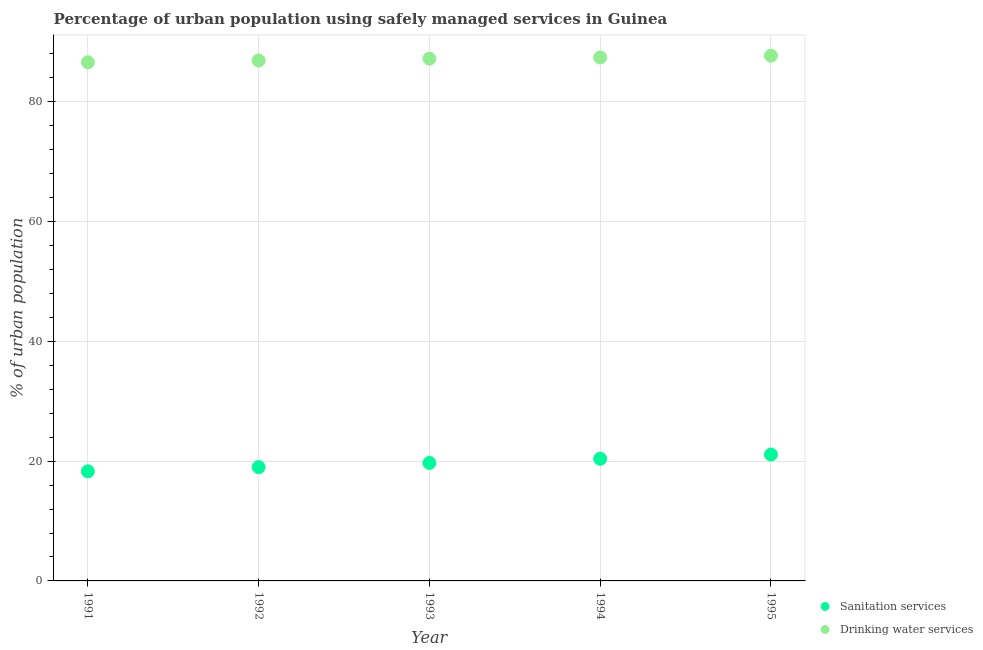How many different coloured dotlines are there?
Your answer should be very brief. 2. Across all years, what is the maximum percentage of urban population who used drinking water services?
Offer a terse response. 87.7. What is the total percentage of urban population who used drinking water services in the graph?
Keep it short and to the point. 435.8. What is the difference between the percentage of urban population who used drinking water services in 1994 and that in 1995?
Make the answer very short. -0.3. What is the difference between the percentage of urban population who used sanitation services in 1994 and the percentage of urban population who used drinking water services in 1992?
Ensure brevity in your answer.  -66.5. What is the average percentage of urban population who used drinking water services per year?
Your response must be concise. 87.16. In the year 1992, what is the difference between the percentage of urban population who used drinking water services and percentage of urban population who used sanitation services?
Your response must be concise. 67.9. What is the ratio of the percentage of urban population who used drinking water services in 1991 to that in 1994?
Ensure brevity in your answer.  0.99. Is the percentage of urban population who used drinking water services in 1992 less than that in 1995?
Your response must be concise. Yes. Is the difference between the percentage of urban population who used sanitation services in 1991 and 1992 greater than the difference between the percentage of urban population who used drinking water services in 1991 and 1992?
Keep it short and to the point. No. What is the difference between the highest and the second highest percentage of urban population who used drinking water services?
Provide a short and direct response. 0.3. What is the difference between the highest and the lowest percentage of urban population who used drinking water services?
Offer a very short reply. 1.1. In how many years, is the percentage of urban population who used sanitation services greater than the average percentage of urban population who used sanitation services taken over all years?
Your response must be concise. 2. Does the percentage of urban population who used sanitation services monotonically increase over the years?
Keep it short and to the point. Yes. Is the percentage of urban population who used drinking water services strictly less than the percentage of urban population who used sanitation services over the years?
Offer a very short reply. No. How many dotlines are there?
Provide a short and direct response. 2. What is the difference between two consecutive major ticks on the Y-axis?
Offer a terse response. 20. Does the graph contain grids?
Make the answer very short. Yes. How many legend labels are there?
Make the answer very short. 2. What is the title of the graph?
Ensure brevity in your answer.  Percentage of urban population using safely managed services in Guinea. Does "% of gross capital formation" appear as one of the legend labels in the graph?
Ensure brevity in your answer.  No. What is the label or title of the Y-axis?
Ensure brevity in your answer.  % of urban population. What is the % of urban population in Drinking water services in 1991?
Ensure brevity in your answer.  86.6. What is the % of urban population of Sanitation services in 1992?
Provide a succinct answer. 19. What is the % of urban population of Drinking water services in 1992?
Your answer should be very brief. 86.9. What is the % of urban population in Sanitation services in 1993?
Your answer should be very brief. 19.7. What is the % of urban population in Drinking water services in 1993?
Your answer should be very brief. 87.2. What is the % of urban population of Sanitation services in 1994?
Your answer should be very brief. 20.4. What is the % of urban population in Drinking water services in 1994?
Give a very brief answer. 87.4. What is the % of urban population of Sanitation services in 1995?
Ensure brevity in your answer.  21.1. What is the % of urban population in Drinking water services in 1995?
Your response must be concise. 87.7. Across all years, what is the maximum % of urban population of Sanitation services?
Keep it short and to the point. 21.1. Across all years, what is the maximum % of urban population of Drinking water services?
Ensure brevity in your answer.  87.7. Across all years, what is the minimum % of urban population in Drinking water services?
Ensure brevity in your answer.  86.6. What is the total % of urban population in Sanitation services in the graph?
Keep it short and to the point. 98.5. What is the total % of urban population of Drinking water services in the graph?
Give a very brief answer. 435.8. What is the difference between the % of urban population in Sanitation services in 1991 and that in 1992?
Your answer should be very brief. -0.7. What is the difference between the % of urban population in Drinking water services in 1991 and that in 1993?
Give a very brief answer. -0.6. What is the difference between the % of urban population in Sanitation services in 1991 and that in 1994?
Provide a short and direct response. -2.1. What is the difference between the % of urban population in Drinking water services in 1991 and that in 1994?
Your response must be concise. -0.8. What is the difference between the % of urban population of Sanitation services in 1992 and that in 1994?
Ensure brevity in your answer.  -1.4. What is the difference between the % of urban population in Drinking water services in 1992 and that in 1994?
Keep it short and to the point. -0.5. What is the difference between the % of urban population in Drinking water services in 1992 and that in 1995?
Your response must be concise. -0.8. What is the difference between the % of urban population of Drinking water services in 1993 and that in 1994?
Offer a very short reply. -0.2. What is the difference between the % of urban population in Sanitation services in 1993 and that in 1995?
Offer a very short reply. -1.4. What is the difference between the % of urban population in Sanitation services in 1991 and the % of urban population in Drinking water services in 1992?
Provide a succinct answer. -68.6. What is the difference between the % of urban population in Sanitation services in 1991 and the % of urban population in Drinking water services in 1993?
Your answer should be compact. -68.9. What is the difference between the % of urban population of Sanitation services in 1991 and the % of urban population of Drinking water services in 1994?
Your answer should be compact. -69.1. What is the difference between the % of urban population in Sanitation services in 1991 and the % of urban population in Drinking water services in 1995?
Give a very brief answer. -69.4. What is the difference between the % of urban population of Sanitation services in 1992 and the % of urban population of Drinking water services in 1993?
Ensure brevity in your answer.  -68.2. What is the difference between the % of urban population in Sanitation services in 1992 and the % of urban population in Drinking water services in 1994?
Your answer should be very brief. -68.4. What is the difference between the % of urban population of Sanitation services in 1992 and the % of urban population of Drinking water services in 1995?
Offer a very short reply. -68.7. What is the difference between the % of urban population in Sanitation services in 1993 and the % of urban population in Drinking water services in 1994?
Ensure brevity in your answer.  -67.7. What is the difference between the % of urban population in Sanitation services in 1993 and the % of urban population in Drinking water services in 1995?
Your response must be concise. -68. What is the difference between the % of urban population of Sanitation services in 1994 and the % of urban population of Drinking water services in 1995?
Provide a short and direct response. -67.3. What is the average % of urban population in Drinking water services per year?
Offer a terse response. 87.16. In the year 1991, what is the difference between the % of urban population of Sanitation services and % of urban population of Drinking water services?
Offer a very short reply. -68.3. In the year 1992, what is the difference between the % of urban population of Sanitation services and % of urban population of Drinking water services?
Your answer should be very brief. -67.9. In the year 1993, what is the difference between the % of urban population in Sanitation services and % of urban population in Drinking water services?
Keep it short and to the point. -67.5. In the year 1994, what is the difference between the % of urban population in Sanitation services and % of urban population in Drinking water services?
Keep it short and to the point. -67. In the year 1995, what is the difference between the % of urban population in Sanitation services and % of urban population in Drinking water services?
Offer a terse response. -66.6. What is the ratio of the % of urban population of Sanitation services in 1991 to that in 1992?
Provide a succinct answer. 0.96. What is the ratio of the % of urban population of Drinking water services in 1991 to that in 1992?
Your answer should be compact. 1. What is the ratio of the % of urban population in Sanitation services in 1991 to that in 1993?
Ensure brevity in your answer.  0.93. What is the ratio of the % of urban population of Sanitation services in 1991 to that in 1994?
Offer a terse response. 0.9. What is the ratio of the % of urban population of Drinking water services in 1991 to that in 1994?
Your answer should be very brief. 0.99. What is the ratio of the % of urban population of Sanitation services in 1991 to that in 1995?
Make the answer very short. 0.87. What is the ratio of the % of urban population of Drinking water services in 1991 to that in 1995?
Your response must be concise. 0.99. What is the ratio of the % of urban population in Sanitation services in 1992 to that in 1993?
Offer a very short reply. 0.96. What is the ratio of the % of urban population of Drinking water services in 1992 to that in 1993?
Make the answer very short. 1. What is the ratio of the % of urban population in Sanitation services in 1992 to that in 1994?
Provide a succinct answer. 0.93. What is the ratio of the % of urban population in Sanitation services in 1992 to that in 1995?
Your answer should be compact. 0.9. What is the ratio of the % of urban population in Drinking water services in 1992 to that in 1995?
Your answer should be very brief. 0.99. What is the ratio of the % of urban population of Sanitation services in 1993 to that in 1994?
Offer a terse response. 0.97. What is the ratio of the % of urban population in Sanitation services in 1993 to that in 1995?
Offer a terse response. 0.93. What is the ratio of the % of urban population in Drinking water services in 1993 to that in 1995?
Your response must be concise. 0.99. What is the ratio of the % of urban population in Sanitation services in 1994 to that in 1995?
Give a very brief answer. 0.97. What is the difference between the highest and the second highest % of urban population of Drinking water services?
Your answer should be very brief. 0.3. What is the difference between the highest and the lowest % of urban population of Drinking water services?
Your answer should be very brief. 1.1. 